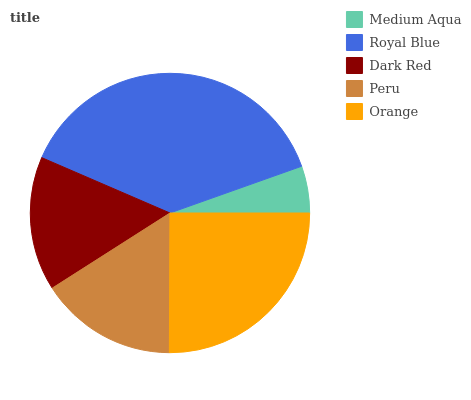Is Medium Aqua the minimum?
Answer yes or no. Yes. Is Royal Blue the maximum?
Answer yes or no. Yes. Is Dark Red the minimum?
Answer yes or no. No. Is Dark Red the maximum?
Answer yes or no. No. Is Royal Blue greater than Dark Red?
Answer yes or no. Yes. Is Dark Red less than Royal Blue?
Answer yes or no. Yes. Is Dark Red greater than Royal Blue?
Answer yes or no. No. Is Royal Blue less than Dark Red?
Answer yes or no. No. Is Peru the high median?
Answer yes or no. Yes. Is Peru the low median?
Answer yes or no. Yes. Is Dark Red the high median?
Answer yes or no. No. Is Medium Aqua the low median?
Answer yes or no. No. 